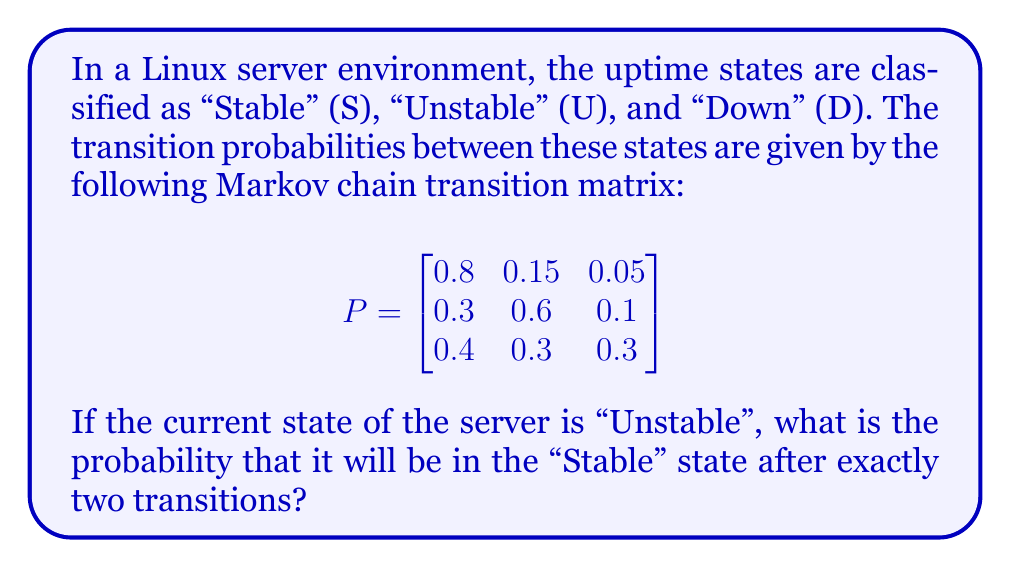Solve this math problem. To solve this problem, we need to use the Chapman-Kolmogorov equations for Markov chains. We want to find the probability of going from the "Unstable" state to the "Stable" state in exactly two steps.

Let's denote the states as:
S = Stable (state 1)
U = Unstable (state 2)
D = Down (state 3)

Step 1: Identify the initial state and target state
- Initial state: Unstable (state 2)
- Target state: Stable (state 1)

Step 2: Calculate the two-step transition probability
We need to calculate $P^2_{21}$, which is the element in the 2nd row and 1st column of the matrix $P^2$.

$$P^2 = P \times P = \begin{bmatrix}
0.8 & 0.15 & 0.05 \\
0.3 & 0.6 & 0.1 \\
0.4 & 0.3 & 0.3
\end{bmatrix} \times \begin{bmatrix}
0.8 & 0.15 & 0.05 \\
0.3 & 0.6 & 0.1 \\
0.4 & 0.3 & 0.3
\end{bmatrix}$$

Step 3: Perform matrix multiplication
$$P^2 = \begin{bmatrix}
0.71 & 0.225 & 0.065 \\
0.51 & 0.39 & 0.10 \\
0.55 & 0.33 & 0.12
\end{bmatrix}$$

Step 4: Identify the required probability
The probability we're looking for is $P^2_{21} = 0.51$

Therefore, the probability that the server will be in the "Stable" state after exactly two transitions, given that it starts in the "Unstable" state, is 0.51 or 51%.
Answer: 0.51 